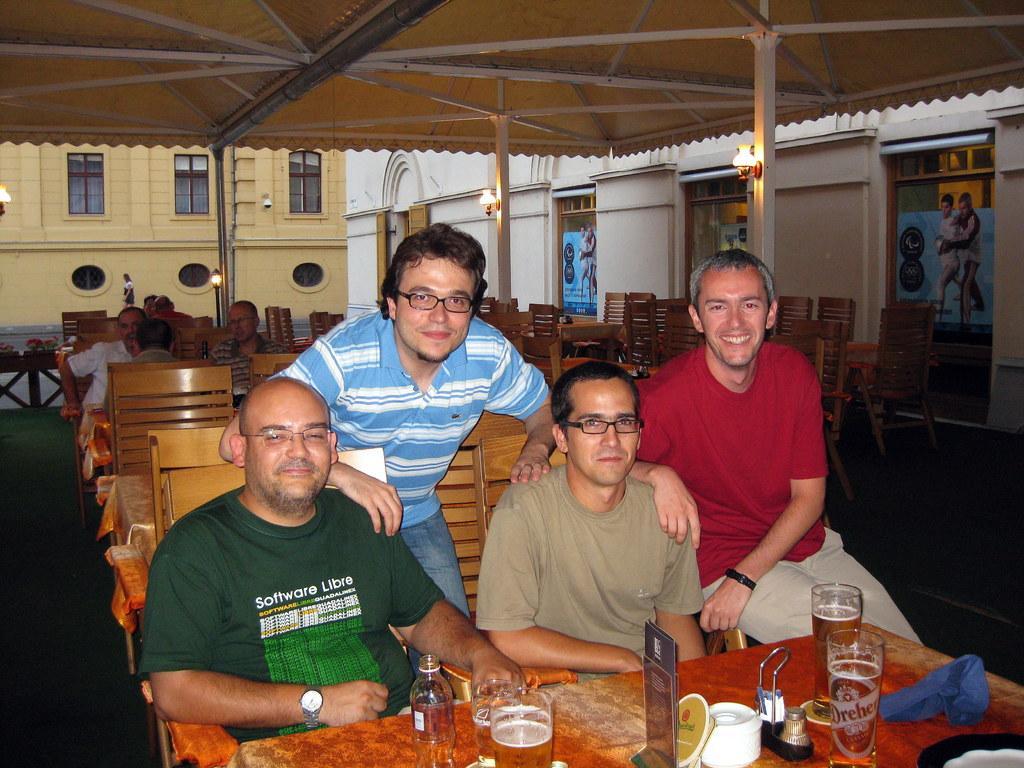Please provide a concise description of this image. In this picture there are three men who are sitting in the chair. There is a man who is standing at the back. There is a glass, bottle, blue cloth and other objects on the table. There are few other people who are sitting on the chair. There is a streetlight , pictures and buildings at the background. 